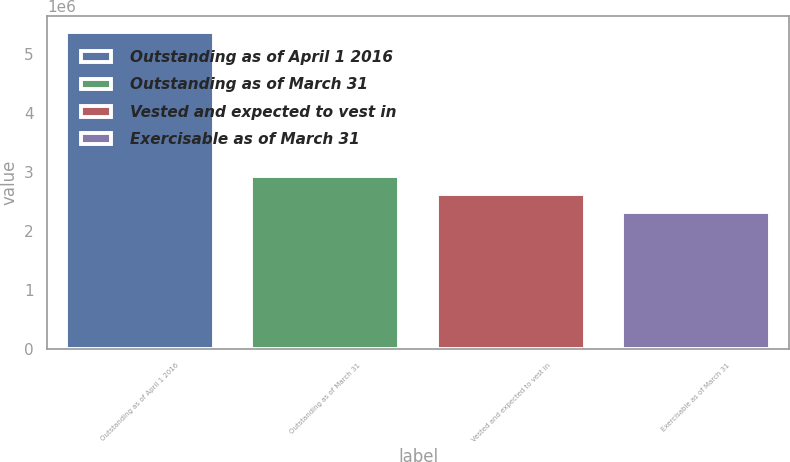Convert chart to OTSL. <chart><loc_0><loc_0><loc_500><loc_500><bar_chart><fcel>Outstanding as of April 1 2016<fcel>Outstanding as of March 31<fcel>Vested and expected to vest in<fcel>Exercisable as of March 31<nl><fcel>5.36662e+06<fcel>2.92469e+06<fcel>2.61945e+06<fcel>2.31421e+06<nl></chart> 